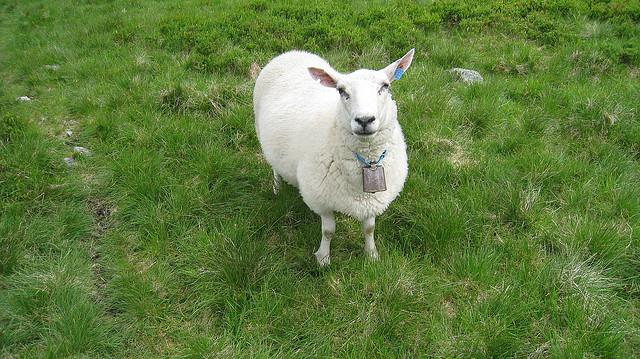Does this animal look friendly?
Concise answer only. Yes. What is the animal wearing around it's neck?
Give a very brief answer. Bell. How many total ears are there in this picture?
Concise answer only. 2. What is the blue item in this animal's ear?
Keep it brief. Tag. 